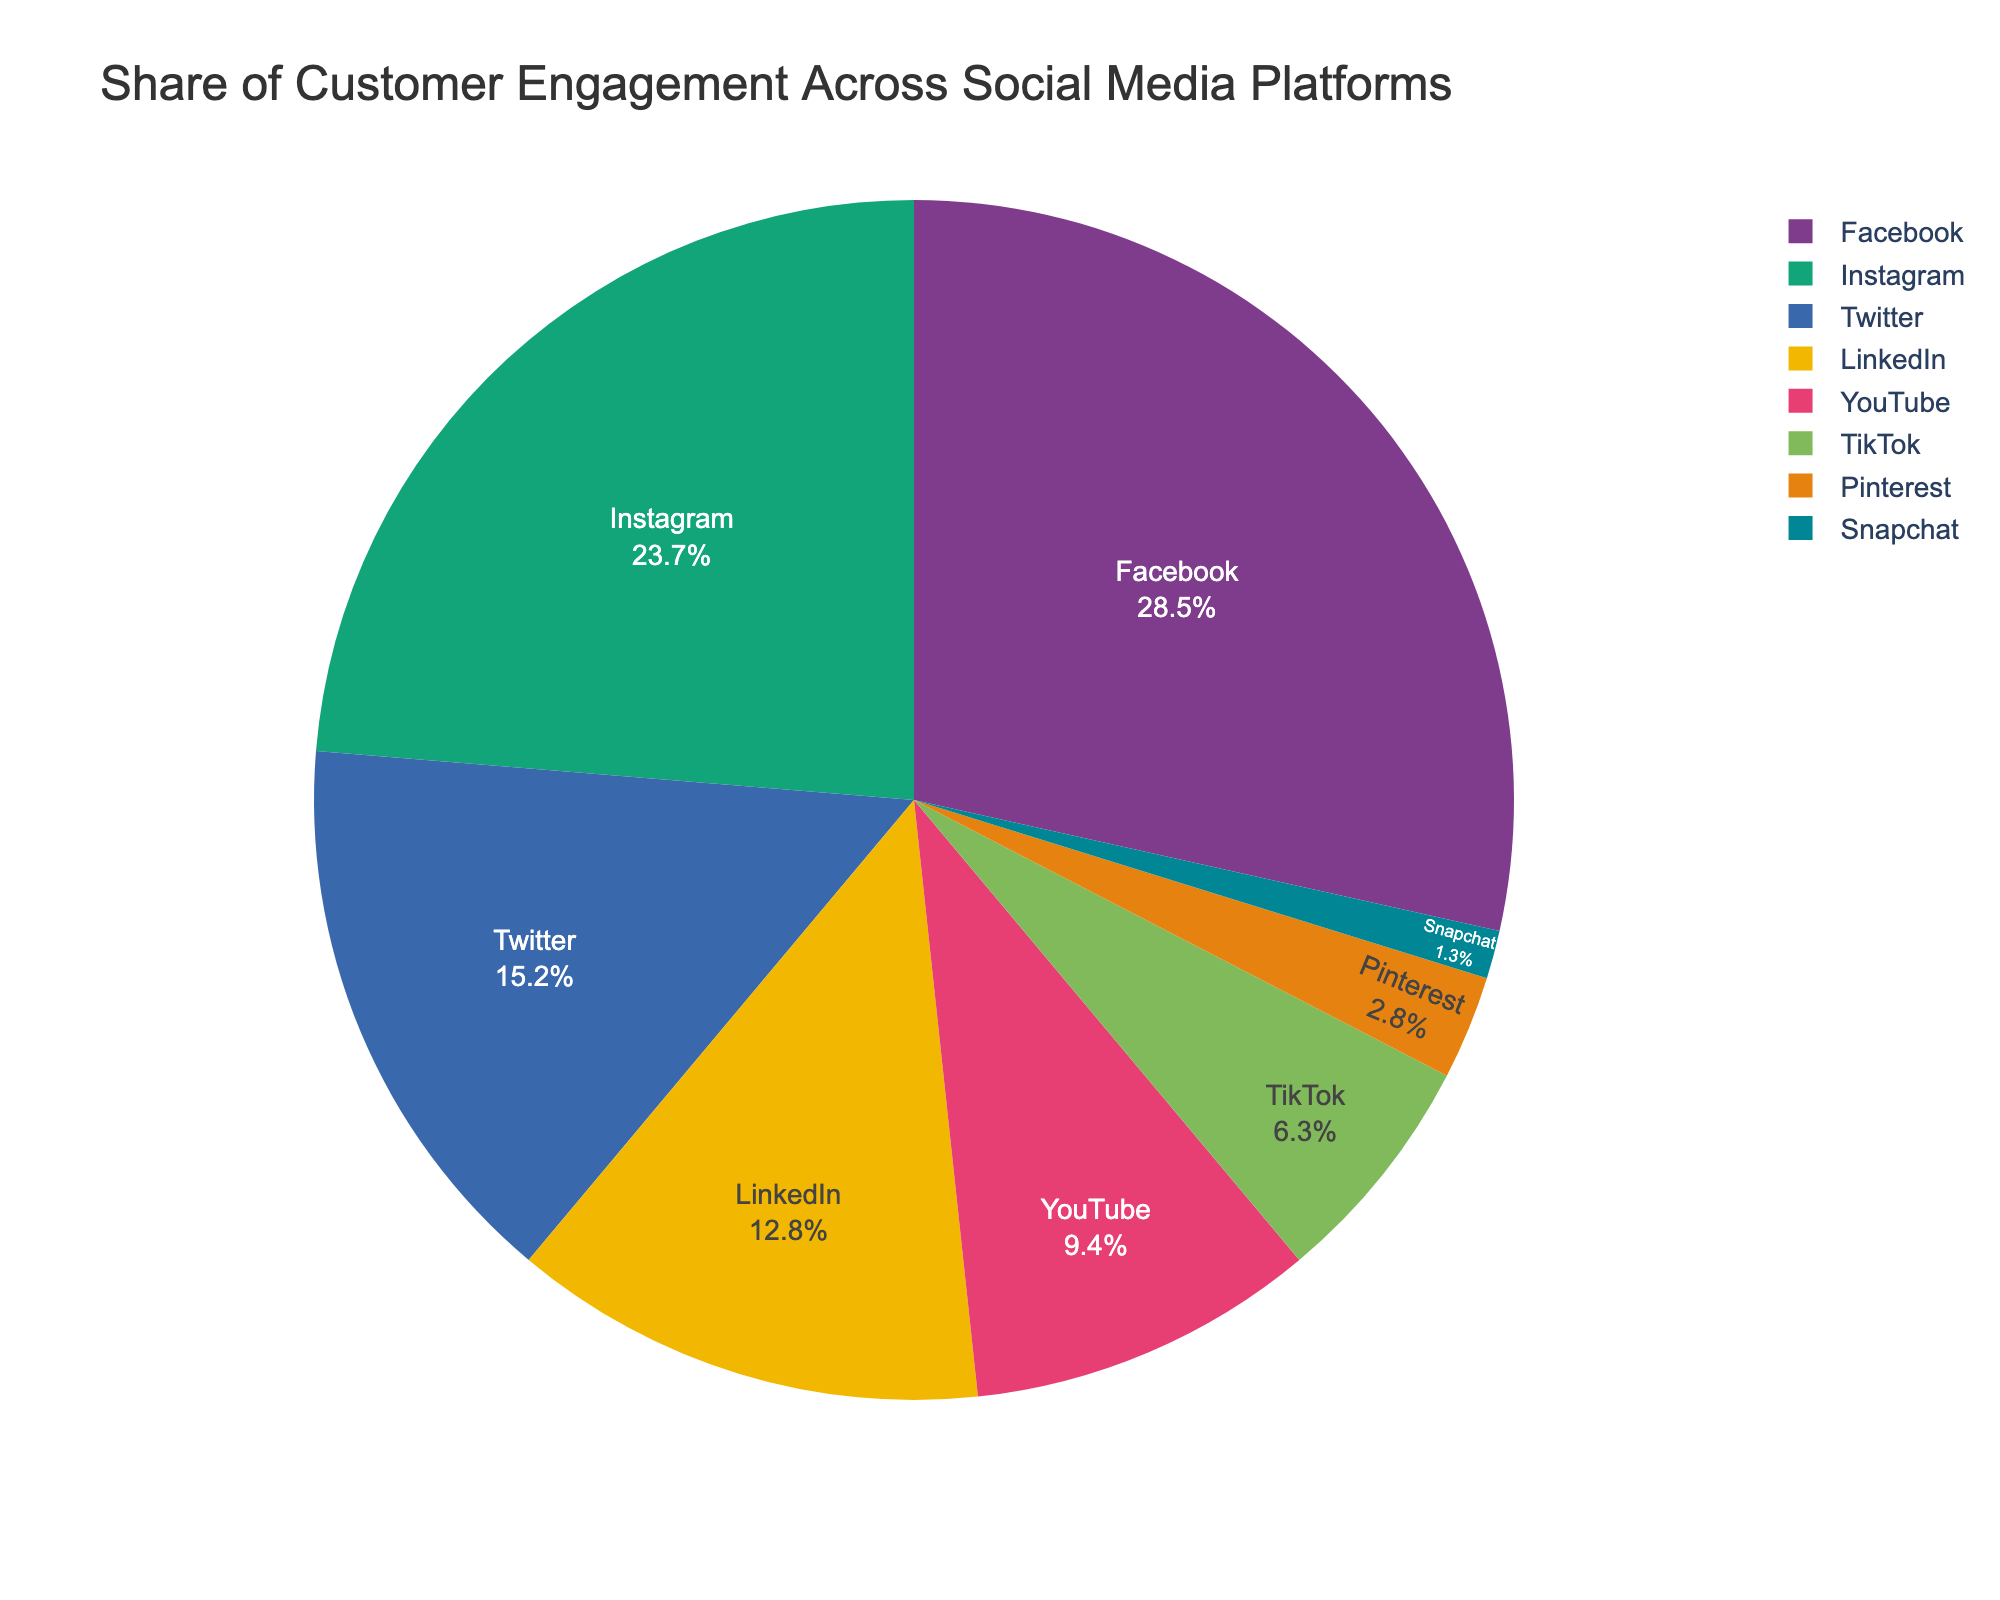What is the share of customer engagement on Instagram? The figure labels each segment with the platform name and its share of customer engagement. Locate the segment for Instagram to find the value.
Answer: 23.7% Which platform has the highest share of customer engagement? The largest segment in the pie chart represents the platform with the highest share. Identify the biggest piece to determine the answer.
Answer: Facebook Which platforms together account for over 50% of customer engagement? To exceed 50%, sum the shares of the largest segments until the sum is over 50%. Start with Facebook (28.5) and add Instagram (23.7). The total is 28.5 + 23.7 = 52.2%.
Answer: Facebook and Instagram How does LinkedIn’s engagement compare to Twitter’s? Find the segments for LinkedIn and Twitter and compare their percentages. LinkedIn has 12.8%, and Twitter has 15.2%. Thus, Twitter has a higher share than LinkedIn.
Answer: Twitter has a higher share How much more engagement does YouTube have compared to Snapchat? Find the segments for YouTube (9.4%) and Snapchat (1.3%) and subtract the smaller value from the larger one. 9.4% - 1.3% = 8.1%.
Answer: 8.1% Are there any platforms with a share of customer engagement below 5%? Identify any segments in the pie chart with values less than 5%. TikTok (6.3%) is above 5%, but Pinterest (2.8%) and Snapchat (1.3%) are below 5%.
Answer: Pinterest, Snapchat Is Twitter’s share closer to LinkedIn’s or Instagram’s? Compare the percentage difference between Twitter (15.2%) and LinkedIn (12.8%) and between Twitter (15.2%) and Instagram (23.7%). The difference with LinkedIn is 15.2% - 12.8% = 2.4%, and with Instagram is 23.7% - 15.2% = 8.5%.
Answer: LinkedIn What is the total share of customer engagement for platforms owned by Meta (Facebook and Instagram)? Sum the shares for Facebook (28.5%) and Instagram (23.7%). 28.5% + 23.7% = 52.2%.
Answer: 52.2% Which platforms have a combined share less than Twitter’s? Find the combined share of smaller platforms and compare it to Twitter’s 15.2%. The combined share of Pinterest (2.8%) and Snapchat (1.3%) is 2.8% + 1.3% = 4.1%, which is less than Twitter's.
Answer: Pinterest and Snapchat 